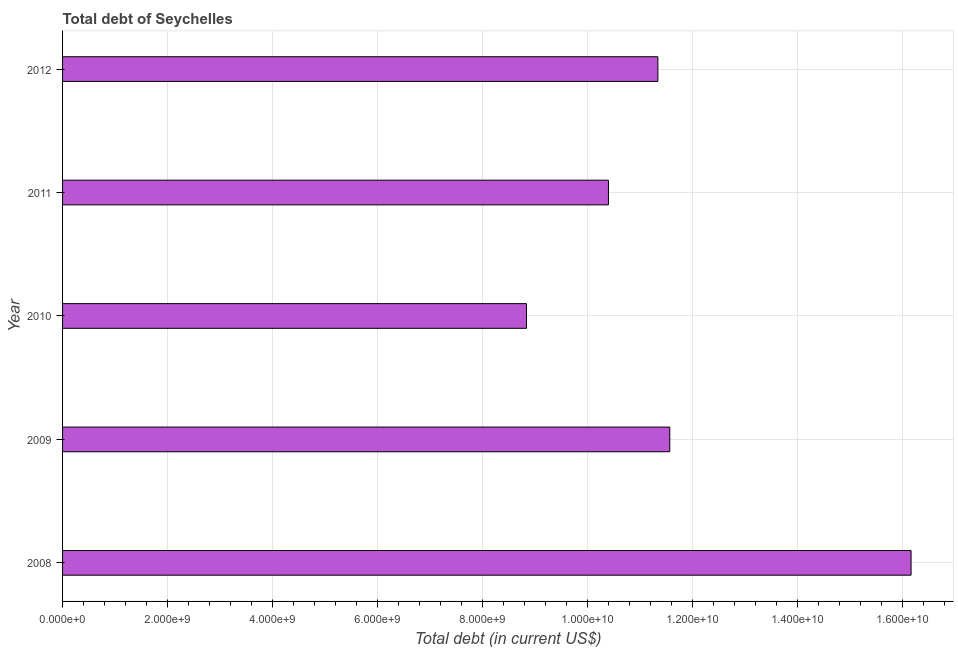Does the graph contain any zero values?
Offer a very short reply. No. Does the graph contain grids?
Your response must be concise. Yes. What is the title of the graph?
Make the answer very short. Total debt of Seychelles. What is the label or title of the X-axis?
Make the answer very short. Total debt (in current US$). What is the total debt in 2008?
Keep it short and to the point. 1.62e+1. Across all years, what is the maximum total debt?
Your answer should be very brief. 1.62e+1. Across all years, what is the minimum total debt?
Offer a very short reply. 8.84e+09. In which year was the total debt minimum?
Provide a short and direct response. 2010. What is the sum of the total debt?
Provide a succinct answer. 5.83e+1. What is the difference between the total debt in 2008 and 2012?
Offer a terse response. 4.83e+09. What is the average total debt per year?
Your response must be concise. 1.17e+1. What is the median total debt?
Make the answer very short. 1.13e+1. In how many years, is the total debt greater than 6400000000 US$?
Keep it short and to the point. 5. What is the ratio of the total debt in 2010 to that in 2012?
Give a very brief answer. 0.78. Is the total debt in 2010 less than that in 2011?
Offer a terse response. Yes. Is the difference between the total debt in 2009 and 2012 greater than the difference between any two years?
Provide a short and direct response. No. What is the difference between the highest and the second highest total debt?
Provide a succinct answer. 4.60e+09. Is the sum of the total debt in 2009 and 2012 greater than the maximum total debt across all years?
Provide a short and direct response. Yes. What is the difference between the highest and the lowest total debt?
Your response must be concise. 7.33e+09. How many years are there in the graph?
Your answer should be very brief. 5. What is the difference between two consecutive major ticks on the X-axis?
Provide a short and direct response. 2.00e+09. Are the values on the major ticks of X-axis written in scientific E-notation?
Provide a succinct answer. Yes. What is the Total debt (in current US$) of 2008?
Your answer should be compact. 1.62e+1. What is the Total debt (in current US$) of 2009?
Give a very brief answer. 1.16e+1. What is the Total debt (in current US$) of 2010?
Keep it short and to the point. 8.84e+09. What is the Total debt (in current US$) of 2011?
Your response must be concise. 1.04e+1. What is the Total debt (in current US$) in 2012?
Provide a short and direct response. 1.13e+1. What is the difference between the Total debt (in current US$) in 2008 and 2009?
Offer a terse response. 4.60e+09. What is the difference between the Total debt (in current US$) in 2008 and 2010?
Make the answer very short. 7.33e+09. What is the difference between the Total debt (in current US$) in 2008 and 2011?
Ensure brevity in your answer.  5.77e+09. What is the difference between the Total debt (in current US$) in 2008 and 2012?
Make the answer very short. 4.83e+09. What is the difference between the Total debt (in current US$) in 2009 and 2010?
Your answer should be compact. 2.73e+09. What is the difference between the Total debt (in current US$) in 2009 and 2011?
Provide a succinct answer. 1.17e+09. What is the difference between the Total debt (in current US$) in 2009 and 2012?
Your response must be concise. 2.27e+08. What is the difference between the Total debt (in current US$) in 2010 and 2011?
Ensure brevity in your answer.  -1.56e+09. What is the difference between the Total debt (in current US$) in 2010 and 2012?
Offer a very short reply. -2.50e+09. What is the difference between the Total debt (in current US$) in 2011 and 2012?
Your answer should be compact. -9.42e+08. What is the ratio of the Total debt (in current US$) in 2008 to that in 2009?
Give a very brief answer. 1.4. What is the ratio of the Total debt (in current US$) in 2008 to that in 2010?
Make the answer very short. 1.83. What is the ratio of the Total debt (in current US$) in 2008 to that in 2011?
Give a very brief answer. 1.55. What is the ratio of the Total debt (in current US$) in 2008 to that in 2012?
Make the answer very short. 1.43. What is the ratio of the Total debt (in current US$) in 2009 to that in 2010?
Provide a succinct answer. 1.31. What is the ratio of the Total debt (in current US$) in 2009 to that in 2011?
Offer a very short reply. 1.11. What is the ratio of the Total debt (in current US$) in 2010 to that in 2012?
Give a very brief answer. 0.78. What is the ratio of the Total debt (in current US$) in 2011 to that in 2012?
Your answer should be very brief. 0.92. 